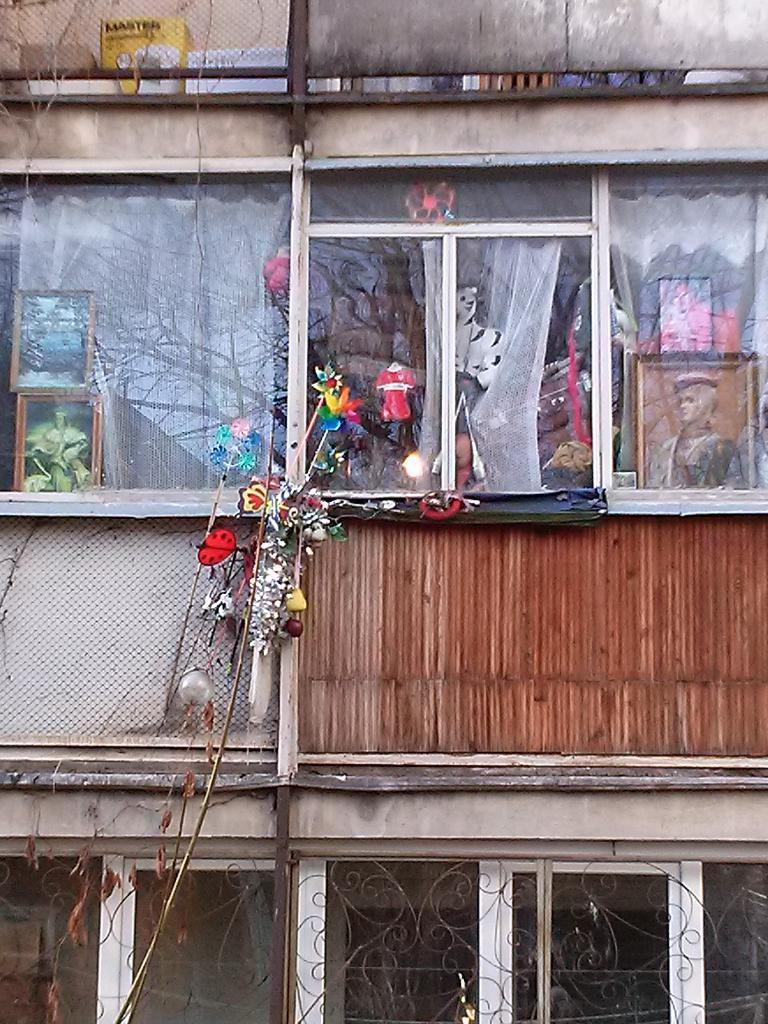What type of structure is visible in the image? There is a building in the image. What feature can be seen on the building? The building has windows. What material are the windows made of? The windows are made of glass. What scientific experiment is being conducted on the building's roof in the image? There is no scientific experiment visible on the building's roof in the image. 